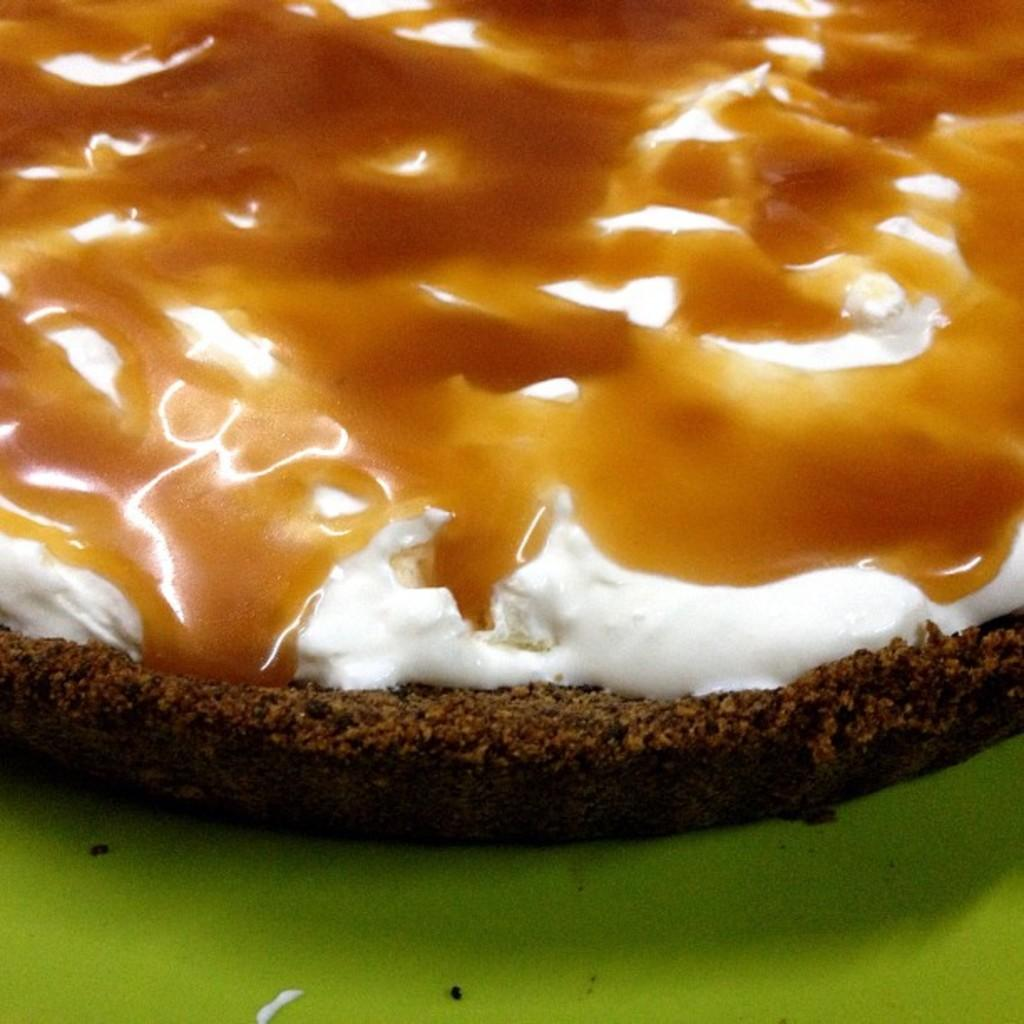What is the main subject of the image? There is a cake in the image. What is the cake placed on? The cake is on a green plate. What can be seen on top of the cake? There is white cream and honey on top of the cake. How many fingers are used to process the cake in the image? There are no fingers or any indication of a process in the image; it simply shows a cake with white cream and honey on top. 